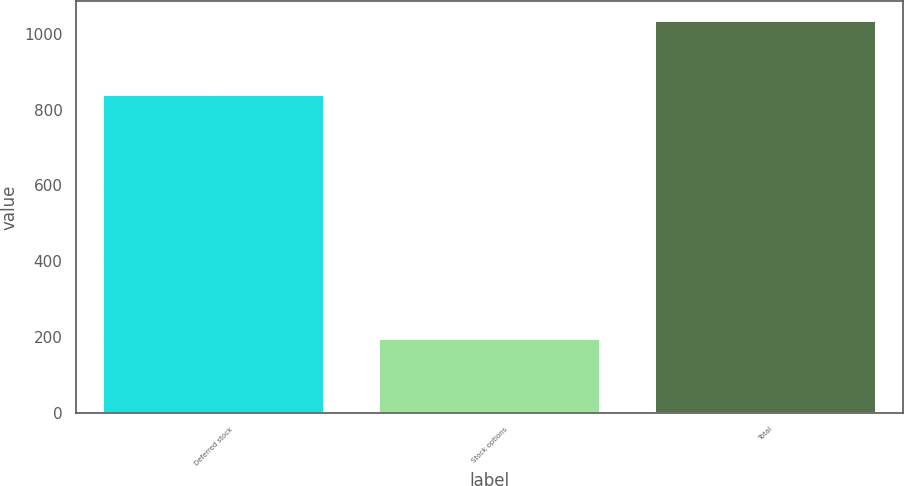Convert chart. <chart><loc_0><loc_0><loc_500><loc_500><bar_chart><fcel>Deferred stock<fcel>Stock options<fcel>Total<nl><fcel>839<fcel>195<fcel>1034<nl></chart> 